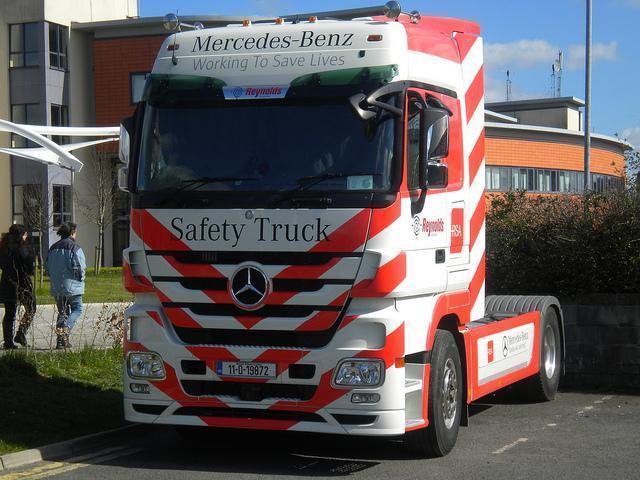How many people can be seen?
Give a very brief answer. 2. 